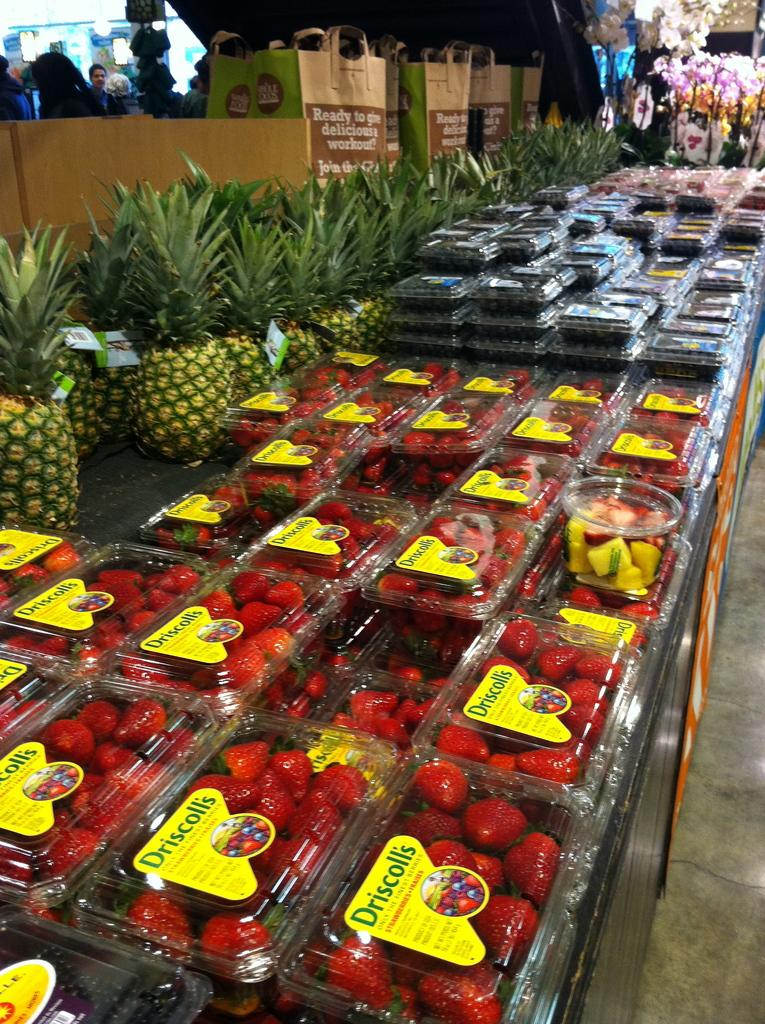What type of fruit is present in the image? There are strawberries and pineapples in the image. What objects are used for carrying items in the image? There are carry bags in the image. How many books can be seen in the image? There are no books present in the image. What type of kitten is sitting on top of the strawberry boxes in the image? There is no kitten present in the image. 